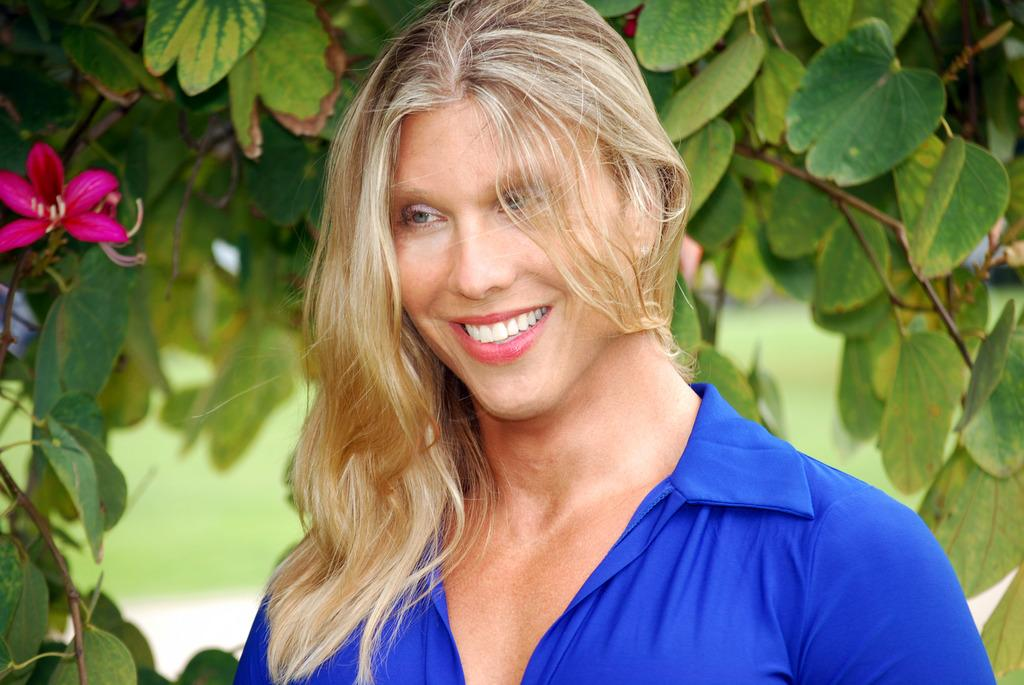Who is the main subject in the image? There is a lady in the image. What is the lady doing in the image? The lady is smiling. What can be seen behind the lady? There are leaves with a flower behind the lady. How would you describe the background of the image? The background of the image is blurred. What is the business rate of the lady in the image? There is no information about a business or rate in the image; it only shows a lady smiling with leaves and a flower behind her. 